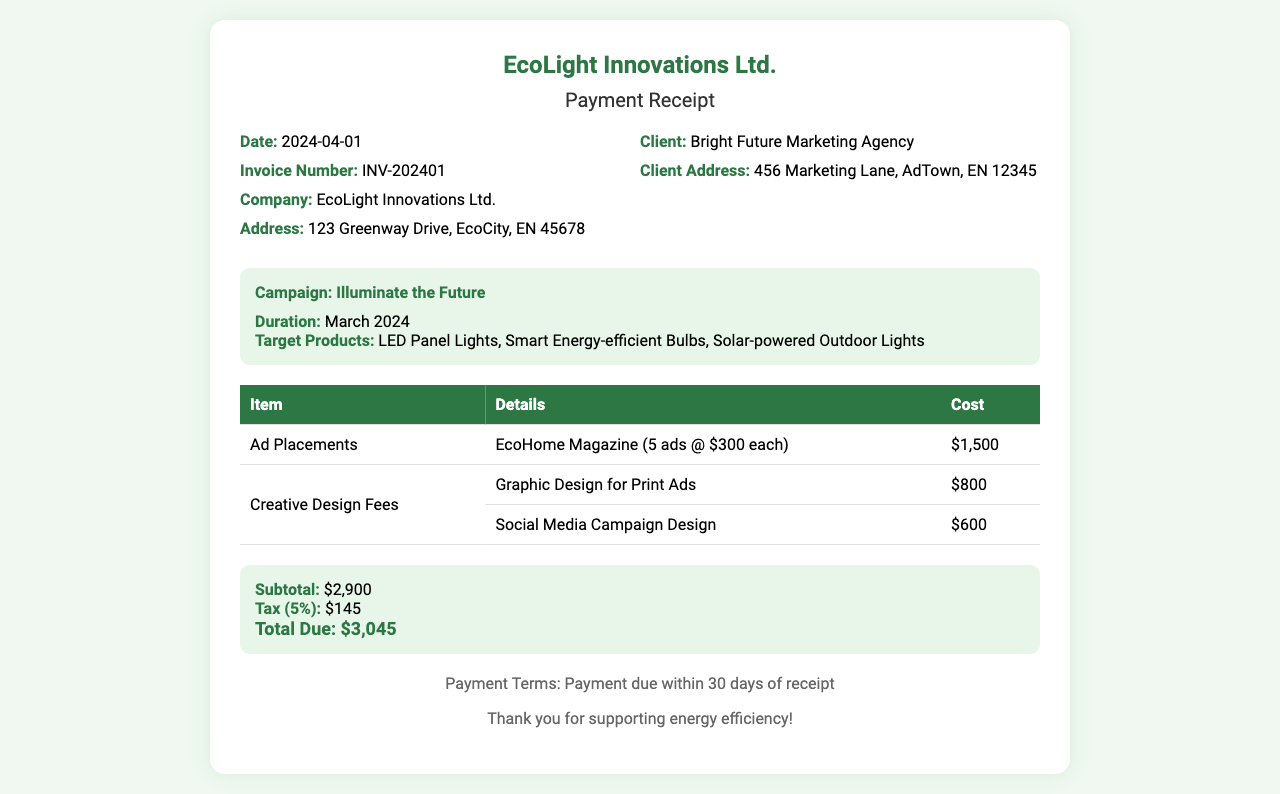what is the date of the receipt? The date of the receipt is stated in the information section of the document.
Answer: 2024-04-01 who is the client for this campaign? The client's name is listed in the info section of the document.
Answer: Bright Future Marketing Agency what is the subtotal amount listed? The subtotal amount is calculated before tax and is found in the summary section.
Answer: $2,900 how many ads were placed in EcoHome Magazine? The number of ads placed is mentioned in the details of the ad placements.
Answer: 5 what is the total due for this receipt? The total due is indicated clearly in the summary section after tax.
Answer: $3,045 what is the campaign title? The campaign title is included in the campaign details section of the receipt.
Answer: Illuminate the Future what items were included in the cost breakdown? The cost breakdown lists specific items and their costs.
Answer: Ad Placements, Creative Design Fees how much was charged for Social Media Campaign Design? The amount charged for Social Media Campaign Design is listed in the cost breakdown table.
Answer: $600 what is the tax rate applied on the subtotal? The tax rate is provided in the summary section, which indicates the percentage applied.
Answer: 5% 